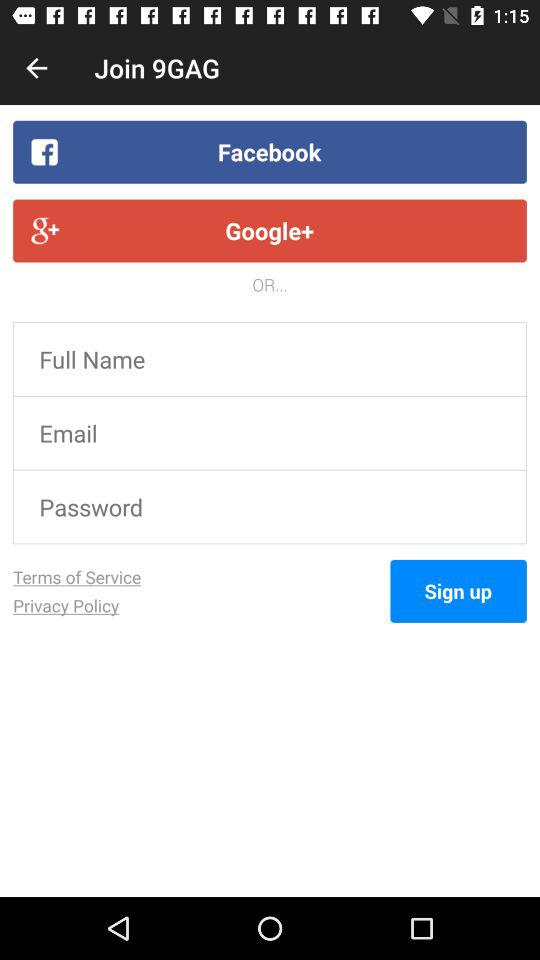What accounts can I use to log in? You can log in with "Facebook", "Google+" and "Email". 